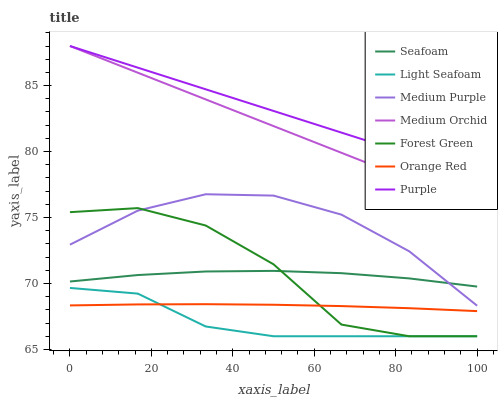Does Light Seafoam have the minimum area under the curve?
Answer yes or no. Yes. Does Purple have the maximum area under the curve?
Answer yes or no. Yes. Does Medium Orchid have the minimum area under the curve?
Answer yes or no. No. Does Medium Orchid have the maximum area under the curve?
Answer yes or no. No. Is Medium Orchid the smoothest?
Answer yes or no. Yes. Is Forest Green the roughest?
Answer yes or no. Yes. Is Seafoam the smoothest?
Answer yes or no. No. Is Seafoam the roughest?
Answer yes or no. No. Does Forest Green have the lowest value?
Answer yes or no. Yes. Does Medium Orchid have the lowest value?
Answer yes or no. No. Does Medium Orchid have the highest value?
Answer yes or no. Yes. Does Seafoam have the highest value?
Answer yes or no. No. Is Light Seafoam less than Medium Purple?
Answer yes or no. Yes. Is Medium Orchid greater than Seafoam?
Answer yes or no. Yes. Does Forest Green intersect Light Seafoam?
Answer yes or no. Yes. Is Forest Green less than Light Seafoam?
Answer yes or no. No. Is Forest Green greater than Light Seafoam?
Answer yes or no. No. Does Light Seafoam intersect Medium Purple?
Answer yes or no. No. 